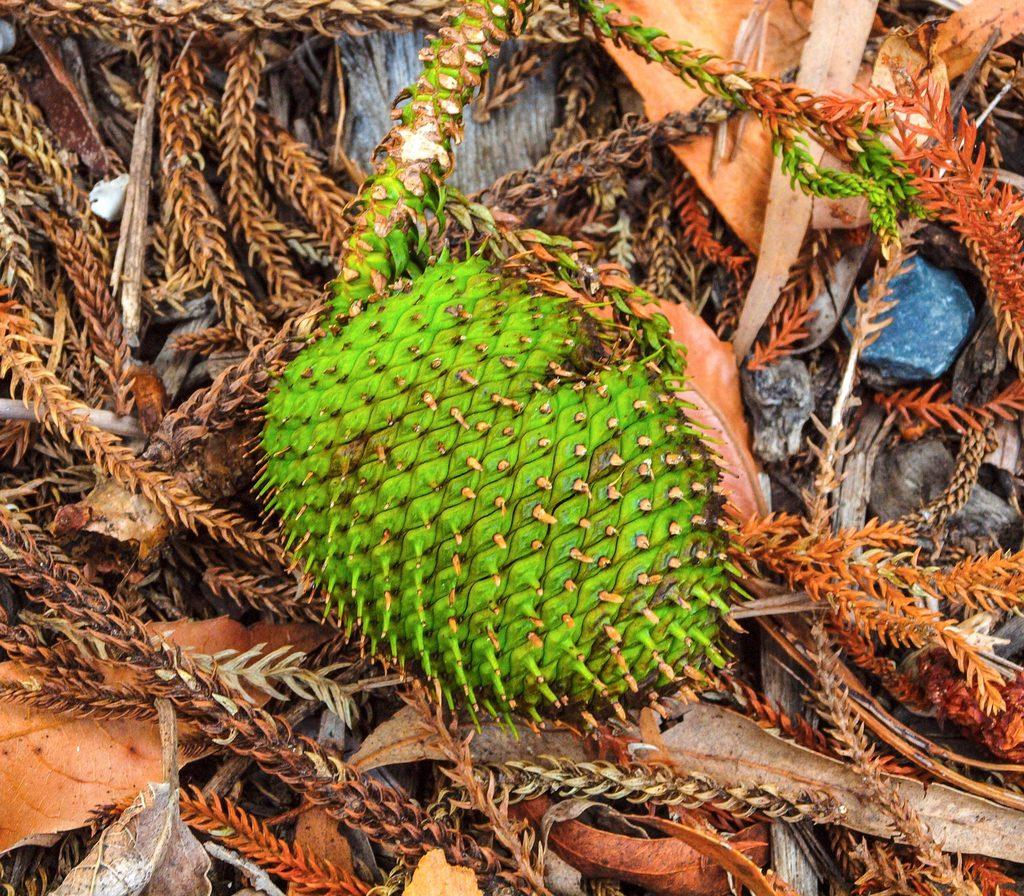What is the main subject in the center of the image? There is fruit in the center of the image. What type of natural elements can be seen in the image? There are dry leaves and stones in the image. Where is the bone located in the image? There is no bone present in the image. What type of trail can be seen in the image? There is no trail present in the image. 